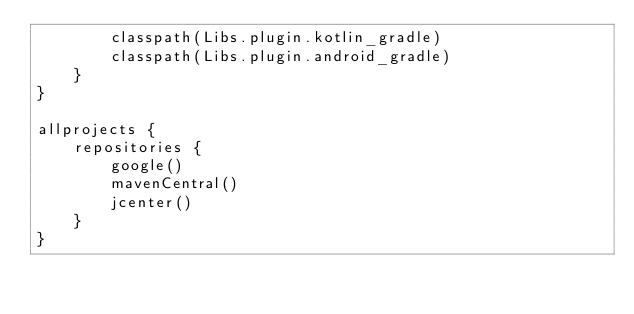Convert code to text. <code><loc_0><loc_0><loc_500><loc_500><_Kotlin_>        classpath(Libs.plugin.kotlin_gradle)
        classpath(Libs.plugin.android_gradle)
    }
}

allprojects {
    repositories {
        google()
        mavenCentral()
        jcenter()
    }
}</code> 